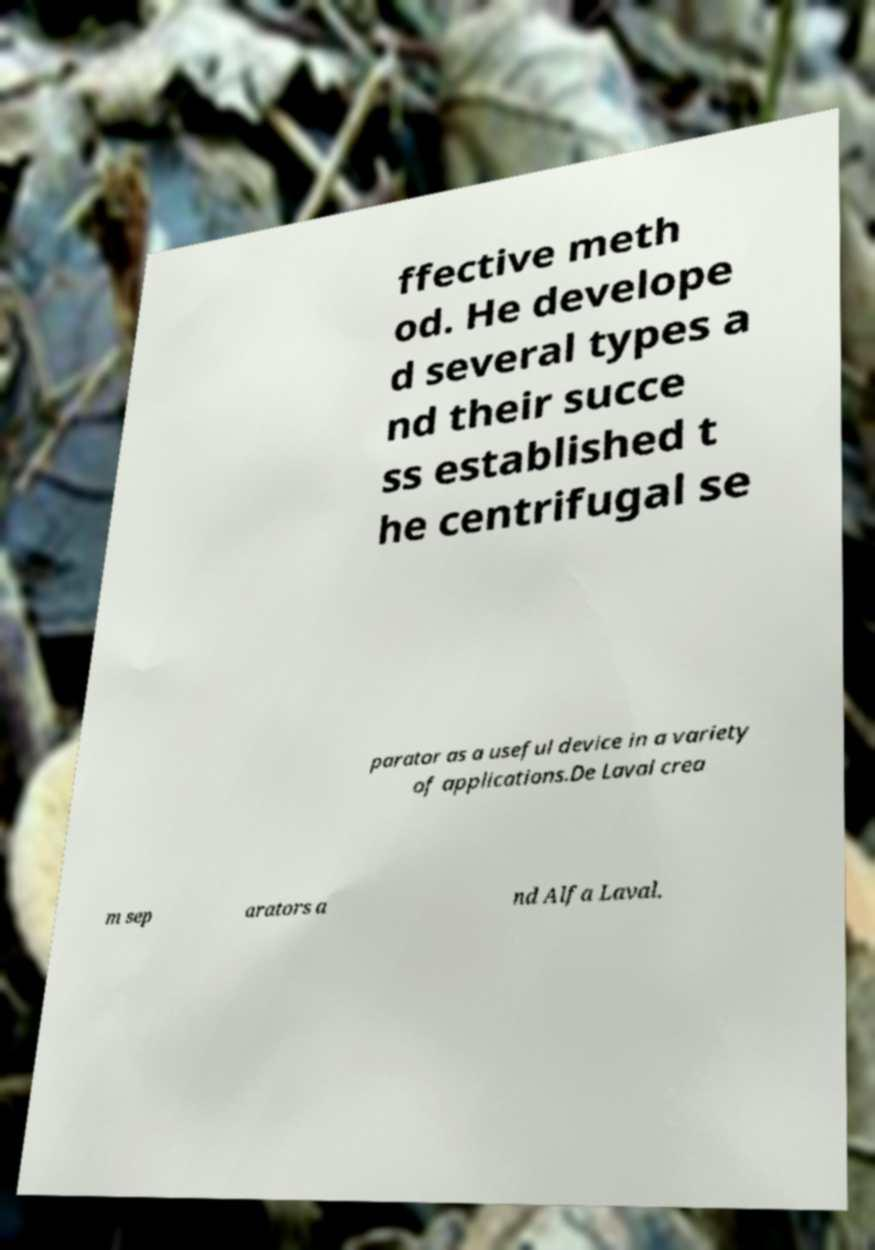For documentation purposes, I need the text within this image transcribed. Could you provide that? ffective meth od. He develope d several types a nd their succe ss established t he centrifugal se parator as a useful device in a variety of applications.De Laval crea m sep arators a nd Alfa Laval. 